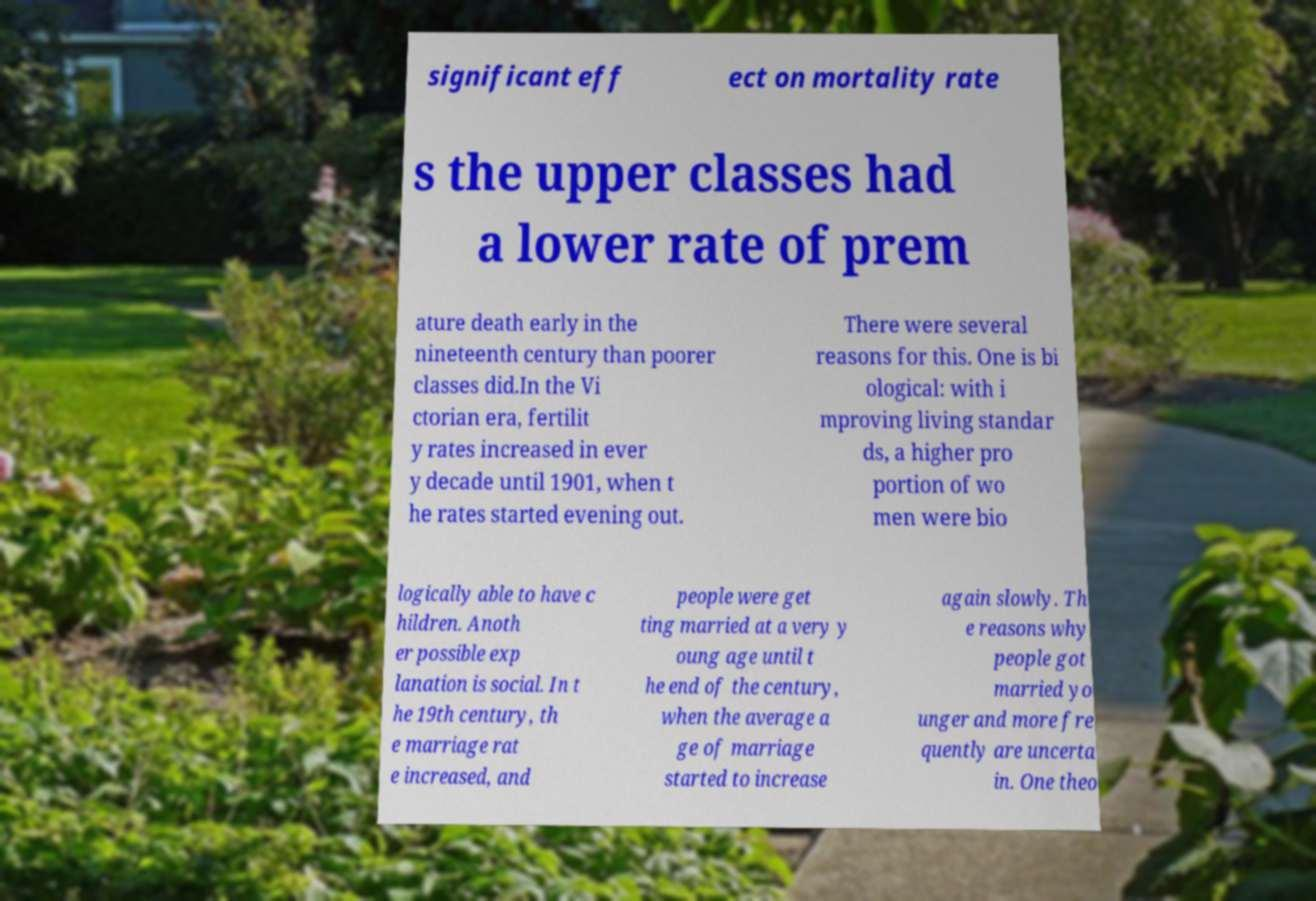Please identify and transcribe the text found in this image. significant eff ect on mortality rate s the upper classes had a lower rate of prem ature death early in the nineteenth century than poorer classes did.In the Vi ctorian era, fertilit y rates increased in ever y decade until 1901, when t he rates started evening out. There were several reasons for this. One is bi ological: with i mproving living standar ds, a higher pro portion of wo men were bio logically able to have c hildren. Anoth er possible exp lanation is social. In t he 19th century, th e marriage rat e increased, and people were get ting married at a very y oung age until t he end of the century, when the average a ge of marriage started to increase again slowly. Th e reasons why people got married yo unger and more fre quently are uncerta in. One theo 